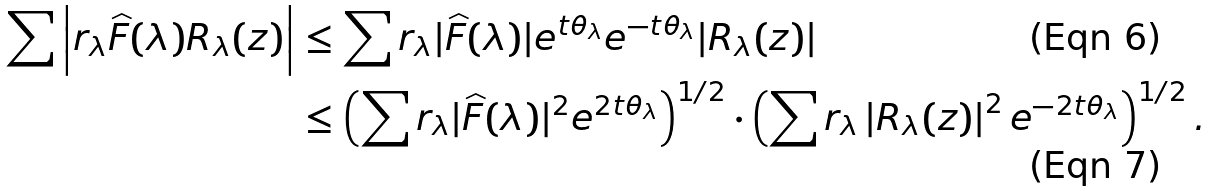<formula> <loc_0><loc_0><loc_500><loc_500>\sum \left | r _ { \lambda } \widehat { F } ( \lambda ) R _ { \lambda } ( z ) \right | & \leq \sum r _ { \lambda } | \widehat { F } ( \lambda ) | e ^ { t \theta _ { \lambda } } e ^ { - t \theta _ { \lambda } } | R _ { \lambda } ( z ) | \\ & \leq \left ( \sum r _ { \lambda } | \widehat { F } ( \lambda ) | ^ { 2 } e ^ { 2 t \theta _ { \lambda } } \right ) ^ { 1 / 2 } \cdot \left ( \sum r _ { \lambda } \left | R _ { \lambda } ( z ) \right | ^ { 2 } e ^ { - 2 t \theta _ { \lambda } } \right ) ^ { 1 / 2 } .</formula> 